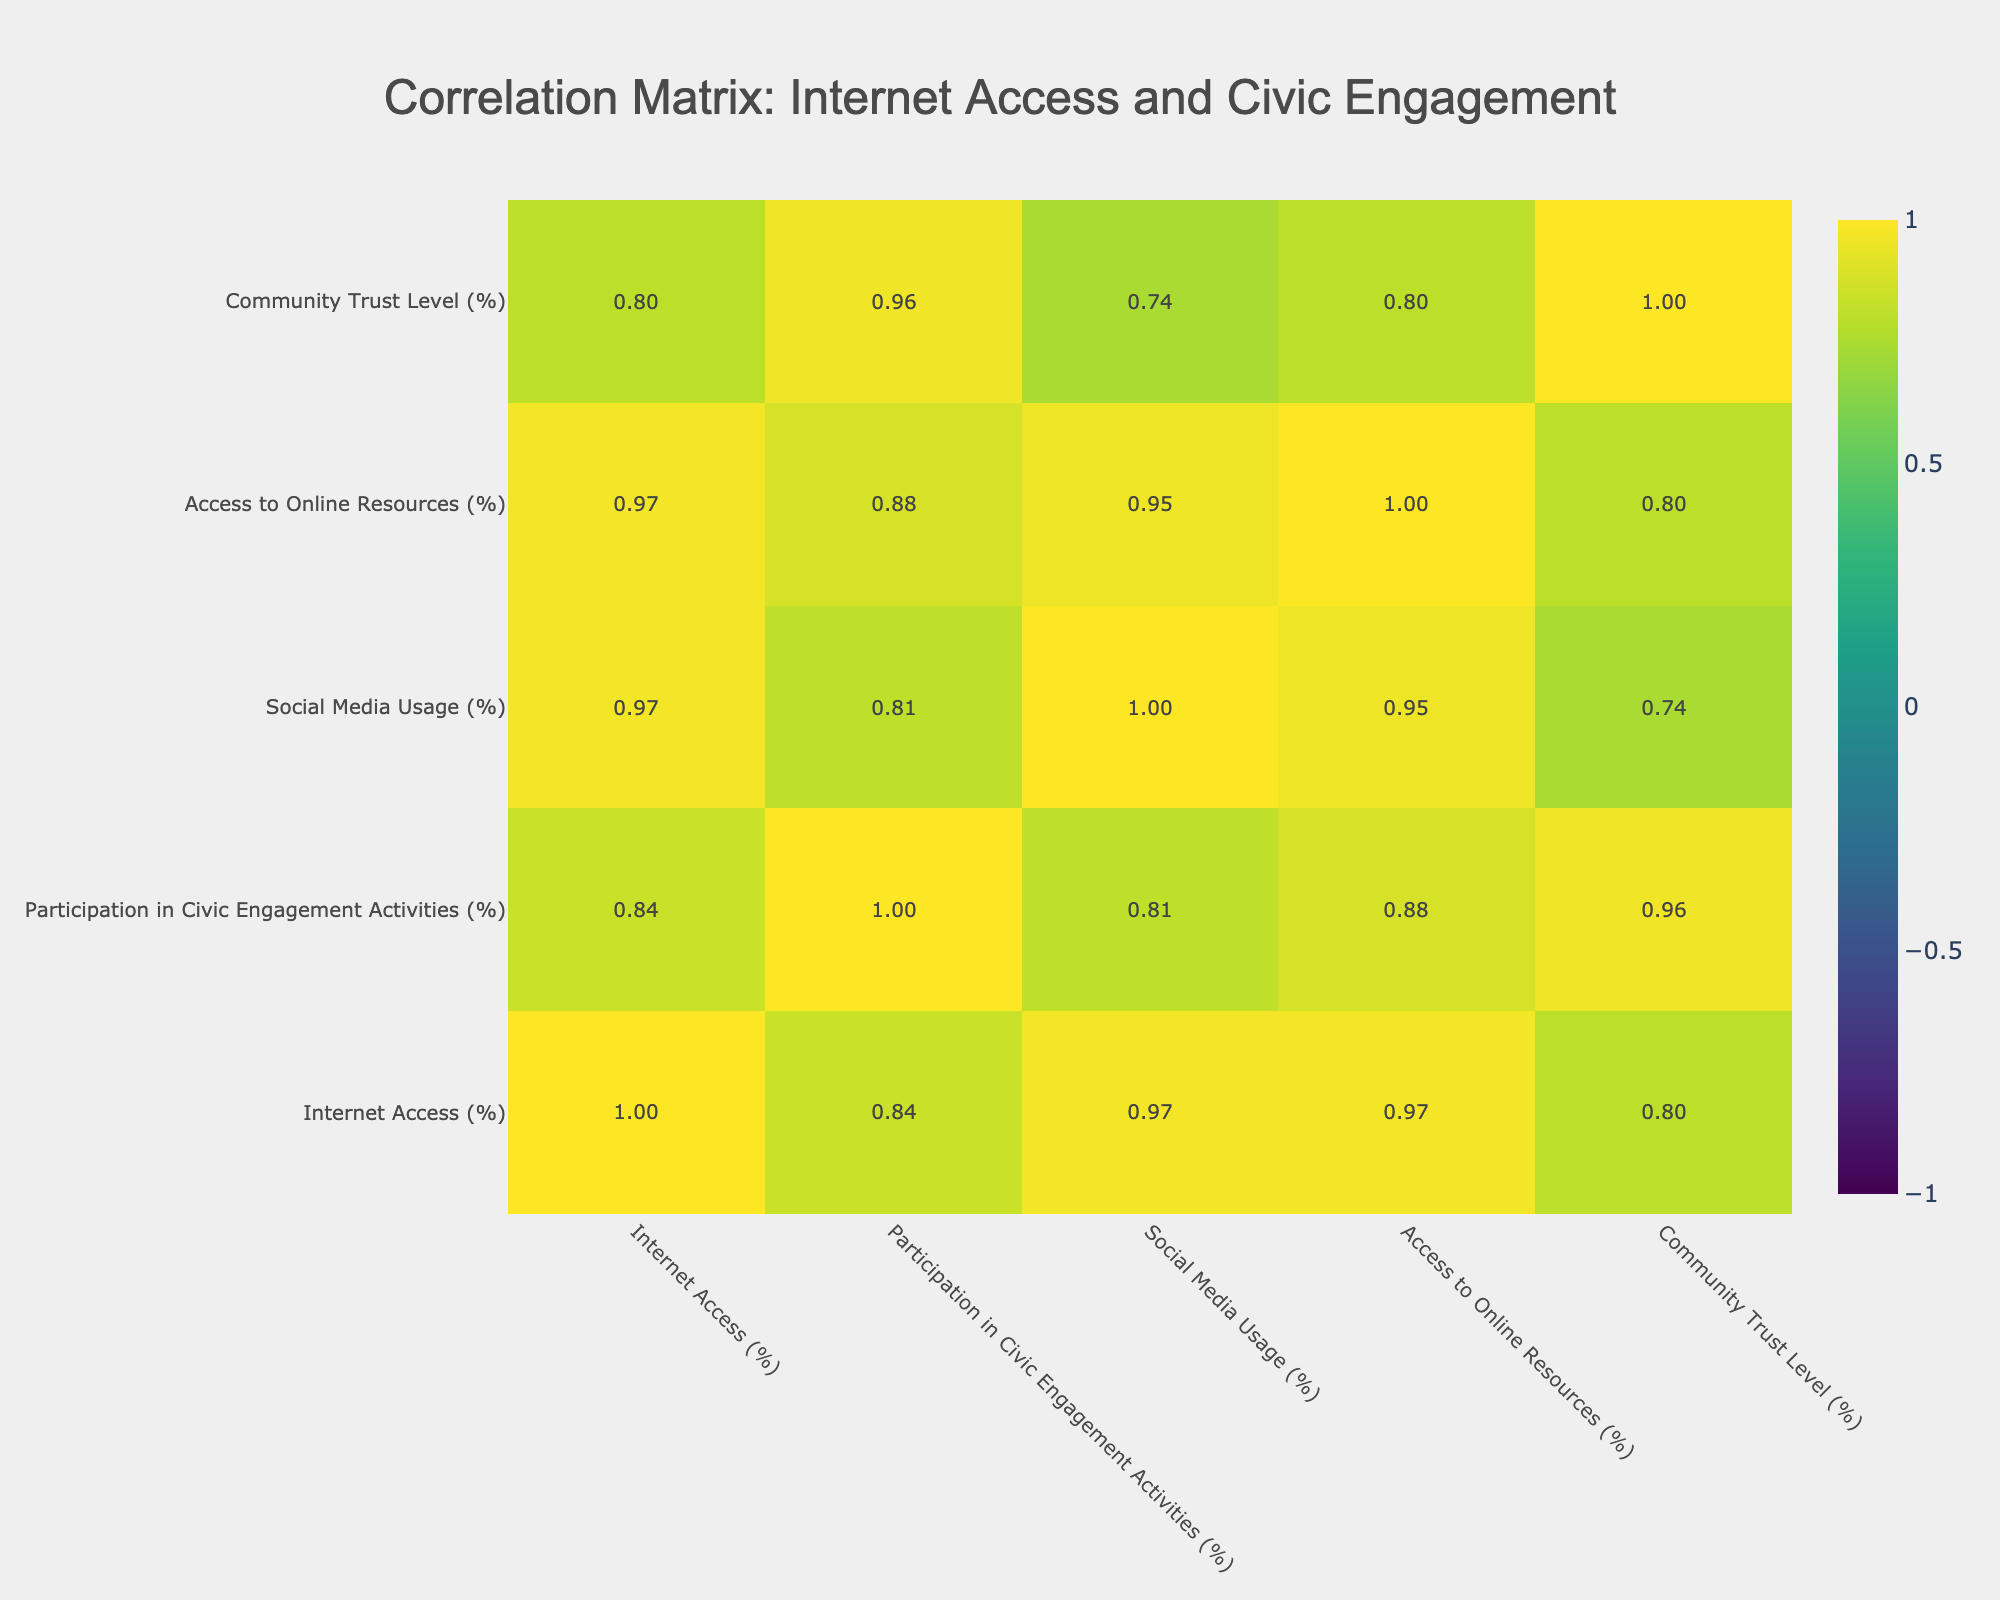What is the correlation between Internet Access and Participation in Civic Engagement Activities? The correlation value shows how strongly two variables are related. In the table, we can refer to the correlation matrix where "Internet Access" and "Participation in Civic Engagement Activities" have a correlation value of 0.73. This indicates a strong positive relationship, meaning as internet access increases, participation in civic engagement activities tends to increase as well.
Answer: 0.73 Which community has the highest percentage of Internet Access? By examining the "Internet Access (%)" column in the table, we see that "Students in Public Schools" has the highest percentage at 80%.
Answer: 80% Do rural communities have higher participation in civic engagement activities compared to urban communities? Looking at the "Participation in Civic Engagement Activities (%)" for rural and urban communities, "Rural Indigenous" (25% participation) and "Low-Income Rural Families" (15% participation) show lower rates compared to urban communities like "Low-Income Urban" (30%) and "Urban Refugee" (35%). Thus, urban communities generally have higher participation.
Answer: No What is the average Internet Access percentage across all communities? To find the average, we sum up the "Internet Access (%)" values: 65 + 40 + 70 + 50 + 55 + 30 + 45 + 60 + 80 + 25 =  630. There are 10 data points, so the average is 630 / 10 = 63.
Answer: 63 Is there a positive correlation between Access to Online Resources and Community Trust Level? Checking the correlation matrix, the correlation value between "Access to Online Resources (%)" and "Community Trust Level (%)" is 0.62. This indicates a moderate positive correlation, meaning access to online resources is likely to be associated with higher community trust levels.
Answer: Yes What is the difference in Participation in Civic Engagement Activities between the highest and lowest communities? The highest participation is from "Students in Public Schools" with 50% and the lowest is "Low-Income Rural Families" with 15%. The difference is 50% - 15% = 35%.
Answer: 35% How many communities have Internet Access greater than 50% and Participation in Civic Engagement Activities greater than 30%? The communities that meet this criterion are "Low-Income Urban" (65% and 30%), "Urban Refugee" (70% and 35%), and "Single Parent Households" (55% and 40%) totaling three communities.
Answer: 3 What is the median value of Social Media Usage among the communities listed? First, we arrange the "Social Media Usage (%)" values: 20, 30, 40, 50, 68, 70, 75, 80, 85. There are 9 data points, the median, being the middle value, is 70%.
Answer: 70% 